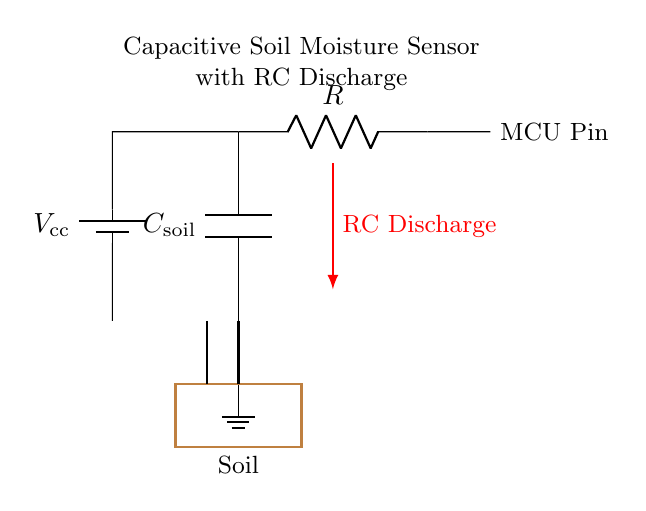What is the value of the capacitor in this circuit? The circuit diagram indicates a capacitor labeled as C soil, but it does not specify a numerical value. Therefore, we cannot determine its value from the diagram alone.
Answer: Not specified What is the main function of this circuit? This circuit is used to measure soil moisture content by charging and discharging the capacitor based on moisture levels. The microcontroller collects and processes this information.
Answer: Soil moisture sensing What type of component is R in this circuit? The component labeled R is a resistor, which limits the current and sets the discharge rate of the capacitor in the circuit.
Answer: Resistor What is the purpose of the RC discharge indicator? The RC discharge arrow indicates the path through which the capacitor discharges after being charged, affecting the time constant and thus the responsiveness of the moisture sensor.
Answer: To show discharge path How does the microcontroller interact with the capacitor? The microcontroller pin connects directly to the capacitor and reads the voltage across the capacitor to determine the moisture level in the soil. It effectively measures the time it takes for the capacitor to discharge and infers moisture content from that data.
Answer: Measures voltage from capacitor What type of circuit is this? This circuit is a Resistor-Capacitor (RC) circuit specifically designed for sensing soil moisture as it utilizes both a resistor and a capacitor to function effectively in the application.
Answer: RC circuit 